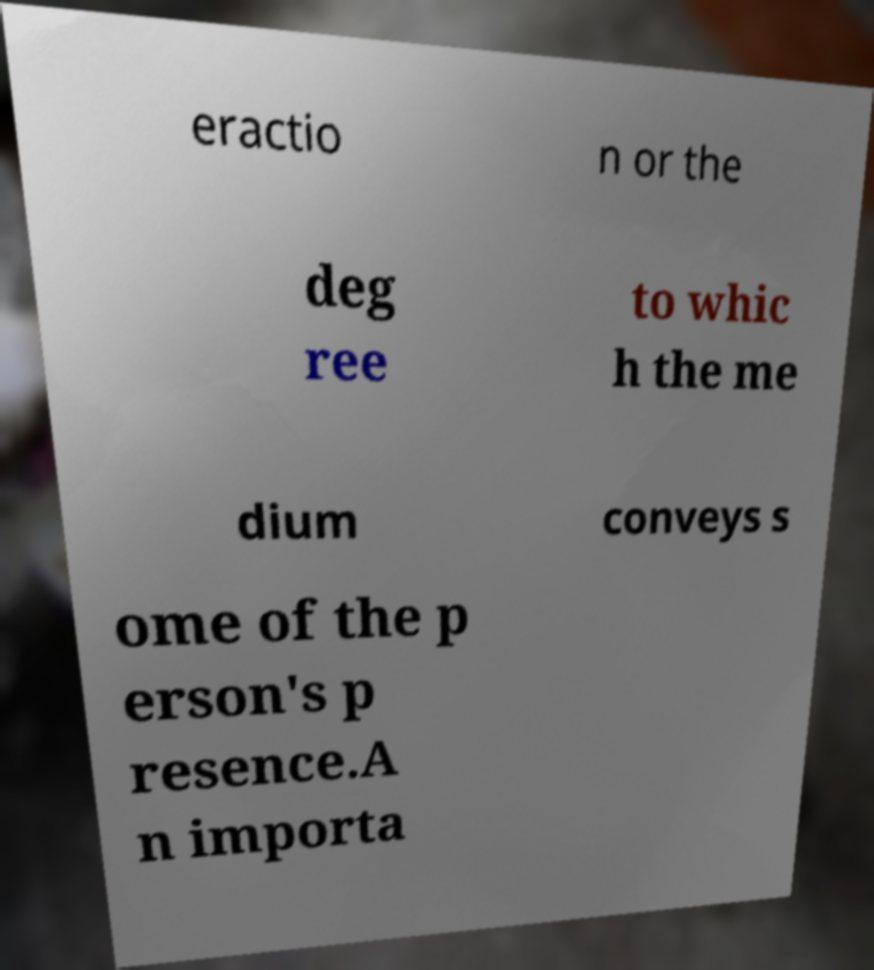Can you accurately transcribe the text from the provided image for me? eractio n or the deg ree to whic h the me dium conveys s ome of the p erson's p resence.A n importa 